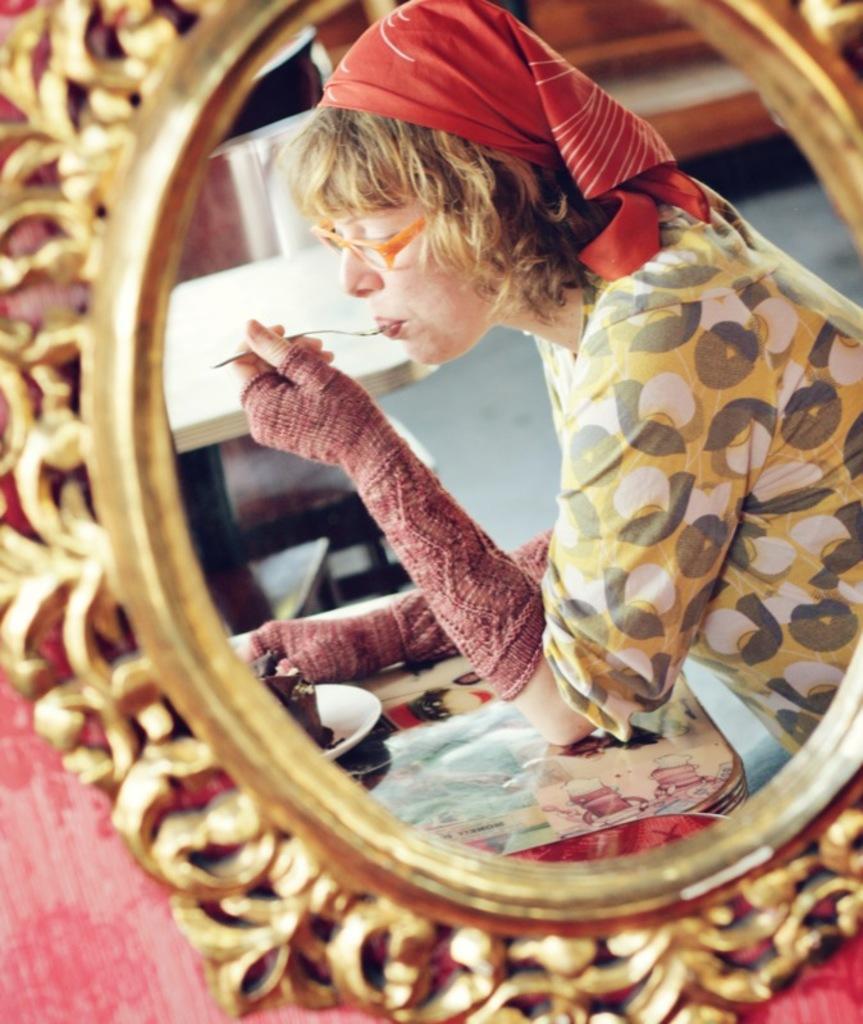Describe this image in one or two sentences. In the foreground of this picture, there is a mirror and through mirror we can see a woman sitting near a table holding a fork in her hand. In the background, there are tables and the floor. 